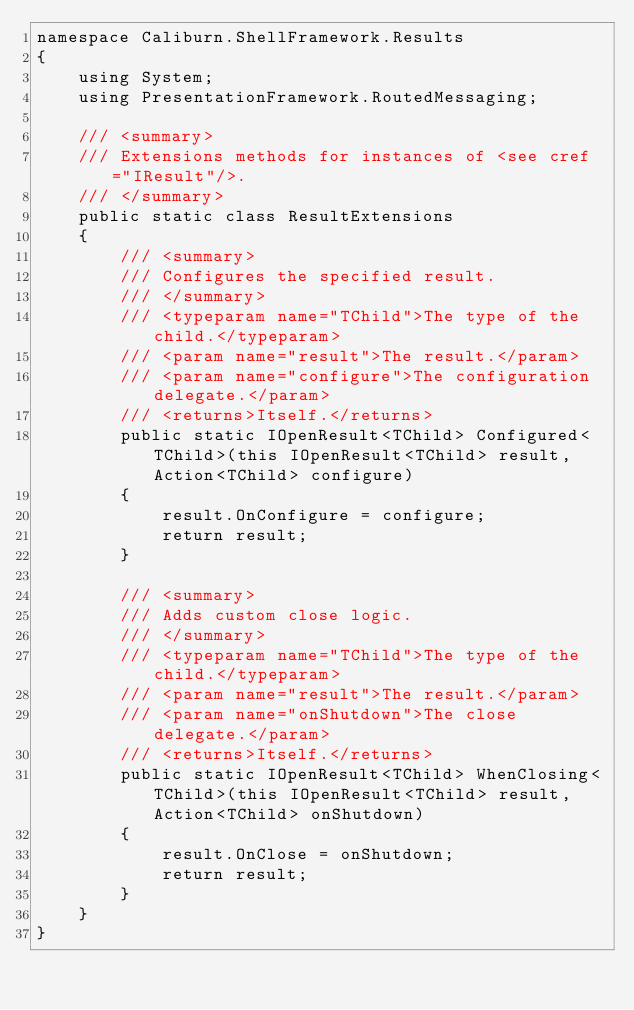Convert code to text. <code><loc_0><loc_0><loc_500><loc_500><_C#_>namespace Caliburn.ShellFramework.Results
{
    using System;
    using PresentationFramework.RoutedMessaging;

    /// <summary>
    /// Extensions methods for instances of <see cref="IResult"/>.
    /// </summary>
    public static class ResultExtensions
    {
        /// <summary>
        /// Configures the specified result.
        /// </summary>
        /// <typeparam name="TChild">The type of the child.</typeparam>
        /// <param name="result">The result.</param>
        /// <param name="configure">The configuration delegate.</param>
        /// <returns>Itself.</returns>
        public static IOpenResult<TChild> Configured<TChild>(this IOpenResult<TChild> result, Action<TChild> configure)
        {
            result.OnConfigure = configure;
            return result;
        }

        /// <summary>
        /// Adds custom close logic.
        /// </summary>
        /// <typeparam name="TChild">The type of the child.</typeparam>
        /// <param name="result">The result.</param>
        /// <param name="onShutdown">The close delegate.</param>
        /// <returns>Itself.</returns>
        public static IOpenResult<TChild> WhenClosing<TChild>(this IOpenResult<TChild> result, Action<TChild> onShutdown)
        {
            result.OnClose = onShutdown;
            return result;
        }
    }
}</code> 